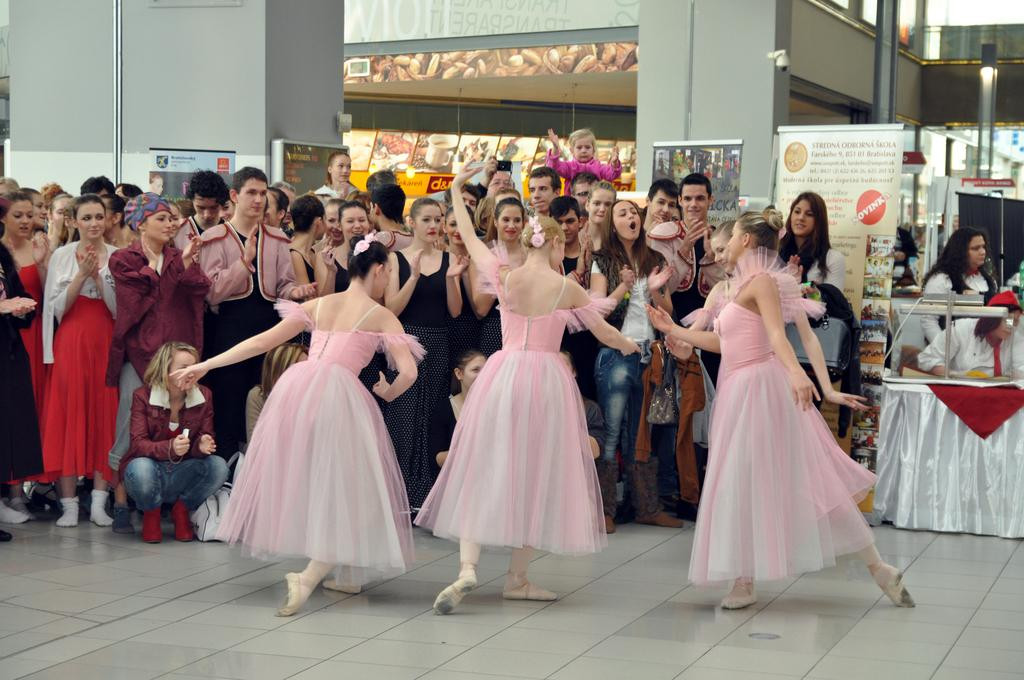What are the people in the image doing? There is a group of people on the floor in the image. What can be seen on the walls in the image? There are posters visible on the walls in the image. What type of material is present in the image? There is cloth in the image. What can be seen in the background of the image? There are objects visible in the background of the image. How many eyes can be seen on the sack in the image? There is no sack present in the image, and therefore no eyes can be seen on it. 